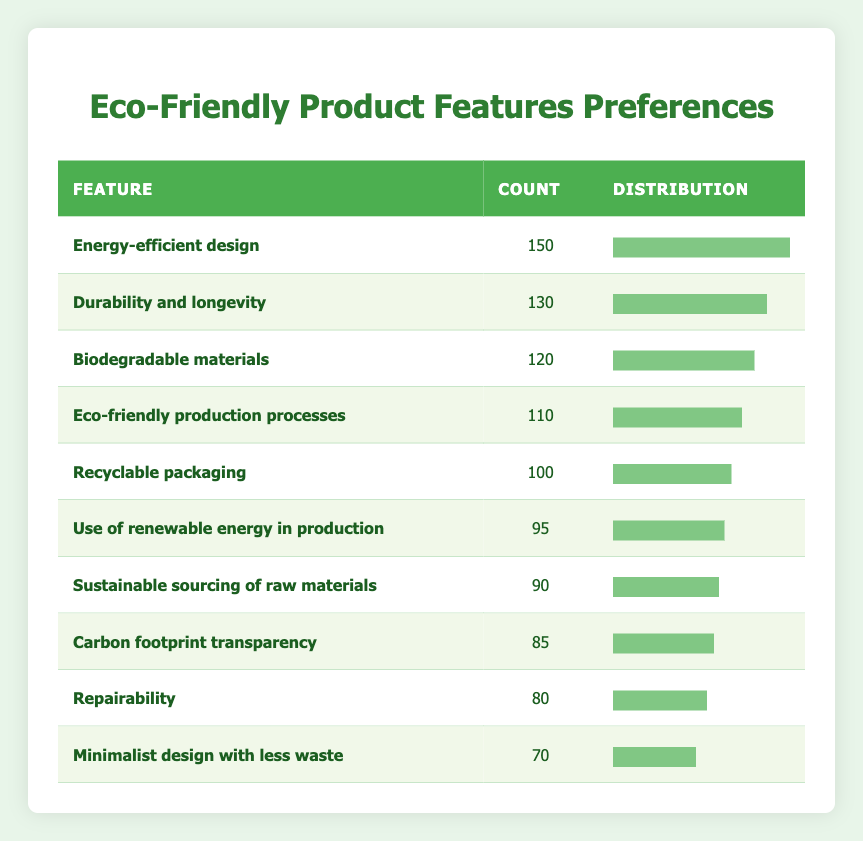What is the most preferred eco-friendly feature among users? The feature with the highest count in the table is "Energy-efficient design," which has 150 preferences.
Answer: Energy-efficient design How many users prefer "Recyclable packaging"? According to the table, "Recyclable packaging" has a count of 100 users indicating their preference.
Answer: 100 What is the count of users who prefer features that relate to sustainability (like 'Sustainable sourcing of raw materials' and 'Repairability')? By adding the counts of the relevant features: 90 (Sustainable sourcing) + 80 (Repairability) = 170.
Answer: 170 Which eco-friendly feature has the least user preferences? "Minimalist design with less waste" has the lowest count at 70, as seen in the table.
Answer: Minimalist design with less waste Is the count for "Use of renewable energy in production" higher than 90? The count for "Use of renewable energy in production" is 95, which is indeed higher than 90.
Answer: Yes What is the difference in user preferences between "Biodegradable materials" and "Carbon footprint transparency"? The count for "Biodegradable materials" is 120 and "Carbon footprint transparency" is 85, so the difference is 120 - 85 = 35.
Answer: 35 Which features have a total count of more than 200 when combined (pick any two)? Combining "Energy-efficient design" (150) and "Durability and longevity" (130) gives a total of 150 + 130 = 280, which is more than 200.
Answer: Yes What percentage of users prefer "Repairability" compared to the total count of preferences? The total count of preferences is 120 + 150 + 100 + 90 + 80 + 110 + 130 + 70 + 95 + 85 = 1,110. The count for "Repairability" is 80, so the percentage is (80/1110) * 100 = 7.2%.
Answer: 7.2% How many features have user preferences greater than 100? The features with counts greater than 100 are "Energy-efficient design" (150), "Durability and longevity" (130), "Biodegradable materials" (120), and "Eco-friendly production processes" (110). There are four features that meet this criterion.
Answer: 4 